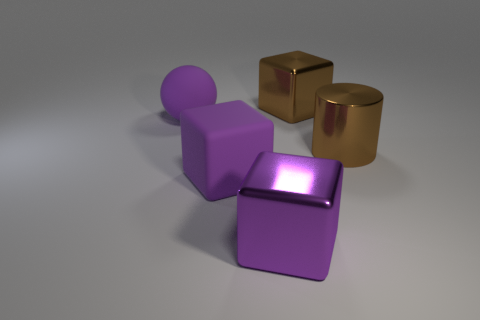Is the color of the shiny cube in front of the ball the same as the ball?
Offer a very short reply. Yes. What number of things are metal cubes that are in front of the large matte cube or metal objects behind the big shiny cylinder?
Offer a very short reply. 2. What is the shape of the big purple metal thing?
Offer a very short reply. Cube. There is a metallic thing that is the same color as the big matte cube; what is its shape?
Offer a terse response. Cube. What number of purple blocks are made of the same material as the large sphere?
Provide a short and direct response. 1. The sphere has what color?
Keep it short and to the point. Purple. There is a matte cube that is the same size as the brown metallic cylinder; what color is it?
Your answer should be very brief. Purple. Is there a matte block that has the same color as the big rubber sphere?
Ensure brevity in your answer.  Yes. Does the metal thing behind the large metallic cylinder have the same shape as the big brown metal thing in front of the purple matte sphere?
Give a very brief answer. No. How many other things are there of the same size as the cylinder?
Your response must be concise. 4. 